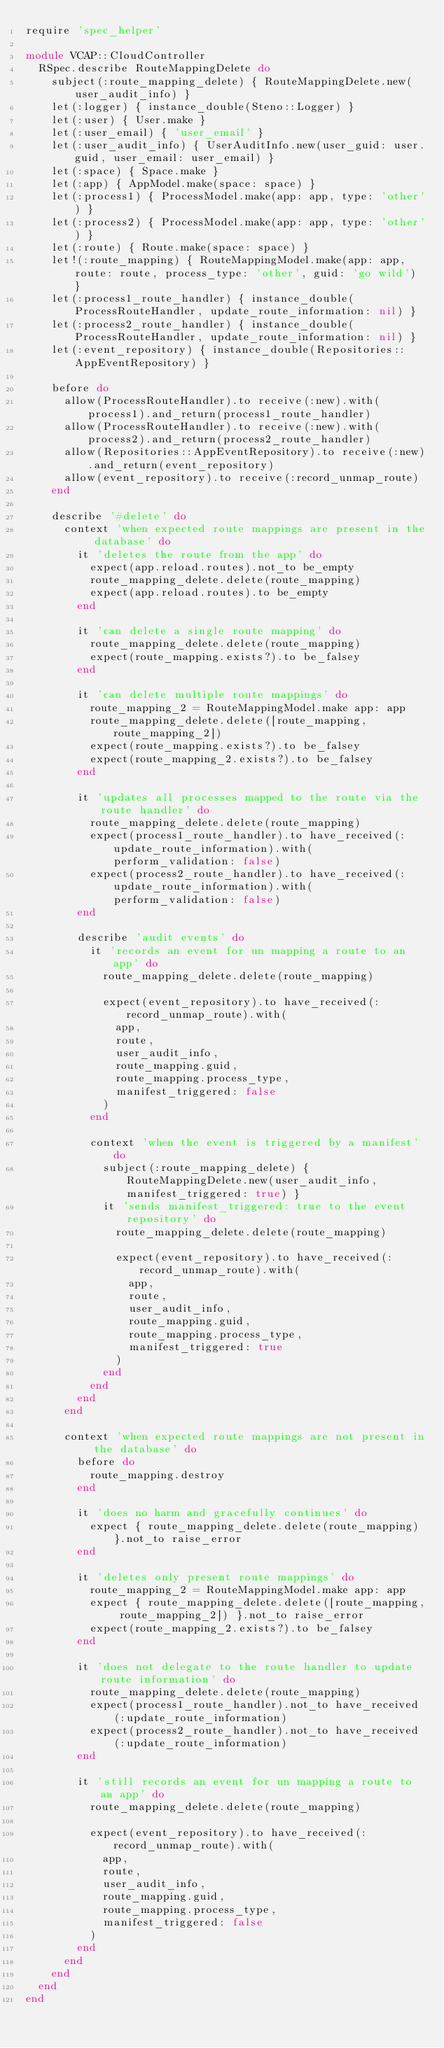Convert code to text. <code><loc_0><loc_0><loc_500><loc_500><_Ruby_>require 'spec_helper'

module VCAP::CloudController
  RSpec.describe RouteMappingDelete do
    subject(:route_mapping_delete) { RouteMappingDelete.new(user_audit_info) }
    let(:logger) { instance_double(Steno::Logger) }
    let(:user) { User.make }
    let(:user_email) { 'user_email' }
    let(:user_audit_info) { UserAuditInfo.new(user_guid: user.guid, user_email: user_email) }
    let(:space) { Space.make }
    let(:app) { AppModel.make(space: space) }
    let(:process1) { ProcessModel.make(app: app, type: 'other') }
    let(:process2) { ProcessModel.make(app: app, type: 'other') }
    let(:route) { Route.make(space: space) }
    let!(:route_mapping) { RouteMappingModel.make(app: app, route: route, process_type: 'other', guid: 'go wild') }
    let(:process1_route_handler) { instance_double(ProcessRouteHandler, update_route_information: nil) }
    let(:process2_route_handler) { instance_double(ProcessRouteHandler, update_route_information: nil) }
    let(:event_repository) { instance_double(Repositories::AppEventRepository) }

    before do
      allow(ProcessRouteHandler).to receive(:new).with(process1).and_return(process1_route_handler)
      allow(ProcessRouteHandler).to receive(:new).with(process2).and_return(process2_route_handler)
      allow(Repositories::AppEventRepository).to receive(:new).and_return(event_repository)
      allow(event_repository).to receive(:record_unmap_route)
    end

    describe '#delete' do
      context 'when expected route mappings are present in the database' do
        it 'deletes the route from the app' do
          expect(app.reload.routes).not_to be_empty
          route_mapping_delete.delete(route_mapping)
          expect(app.reload.routes).to be_empty
        end

        it 'can delete a single route mapping' do
          route_mapping_delete.delete(route_mapping)
          expect(route_mapping.exists?).to be_falsey
        end

        it 'can delete multiple route mappings' do
          route_mapping_2 = RouteMappingModel.make app: app
          route_mapping_delete.delete([route_mapping, route_mapping_2])
          expect(route_mapping.exists?).to be_falsey
          expect(route_mapping_2.exists?).to be_falsey
        end

        it 'updates all processes mapped to the route via the route handler' do
          route_mapping_delete.delete(route_mapping)
          expect(process1_route_handler).to have_received(:update_route_information).with(perform_validation: false)
          expect(process2_route_handler).to have_received(:update_route_information).with(perform_validation: false)
        end

        describe 'audit events' do
          it 'records an event for un mapping a route to an app' do
            route_mapping_delete.delete(route_mapping)

            expect(event_repository).to have_received(:record_unmap_route).with(
              app,
              route,
              user_audit_info,
              route_mapping.guid,
              route_mapping.process_type,
              manifest_triggered: false
            )
          end

          context 'when the event is triggered by a manifest' do
            subject(:route_mapping_delete) { RouteMappingDelete.new(user_audit_info, manifest_triggered: true) }
            it 'sends manifest_triggered: true to the event repository' do
              route_mapping_delete.delete(route_mapping)

              expect(event_repository).to have_received(:record_unmap_route).with(
                app,
                route,
                user_audit_info,
                route_mapping.guid,
                route_mapping.process_type,
                manifest_triggered: true
              )
            end
          end
        end
      end

      context 'when expected route mappings are not present in the database' do
        before do
          route_mapping.destroy
        end

        it 'does no harm and gracefully continues' do
          expect { route_mapping_delete.delete(route_mapping) }.not_to raise_error
        end

        it 'deletes only present route mappings' do
          route_mapping_2 = RouteMappingModel.make app: app
          expect { route_mapping_delete.delete([route_mapping, route_mapping_2]) }.not_to raise_error
          expect(route_mapping_2.exists?).to be_falsey
        end

        it 'does not delegate to the route handler to update route information' do
          route_mapping_delete.delete(route_mapping)
          expect(process1_route_handler).not_to have_received(:update_route_information)
          expect(process2_route_handler).not_to have_received(:update_route_information)
        end

        it 'still records an event for un mapping a route to an app' do
          route_mapping_delete.delete(route_mapping)

          expect(event_repository).to have_received(:record_unmap_route).with(
            app,
            route,
            user_audit_info,
            route_mapping.guid,
            route_mapping.process_type,
            manifest_triggered: false
          )
        end
      end
    end
  end
end
</code> 